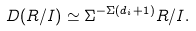Convert formula to latex. <formula><loc_0><loc_0><loc_500><loc_500>D ( R / I ) \simeq \Sigma ^ { - \Sigma ( d _ { i } + 1 ) } R / I .</formula> 